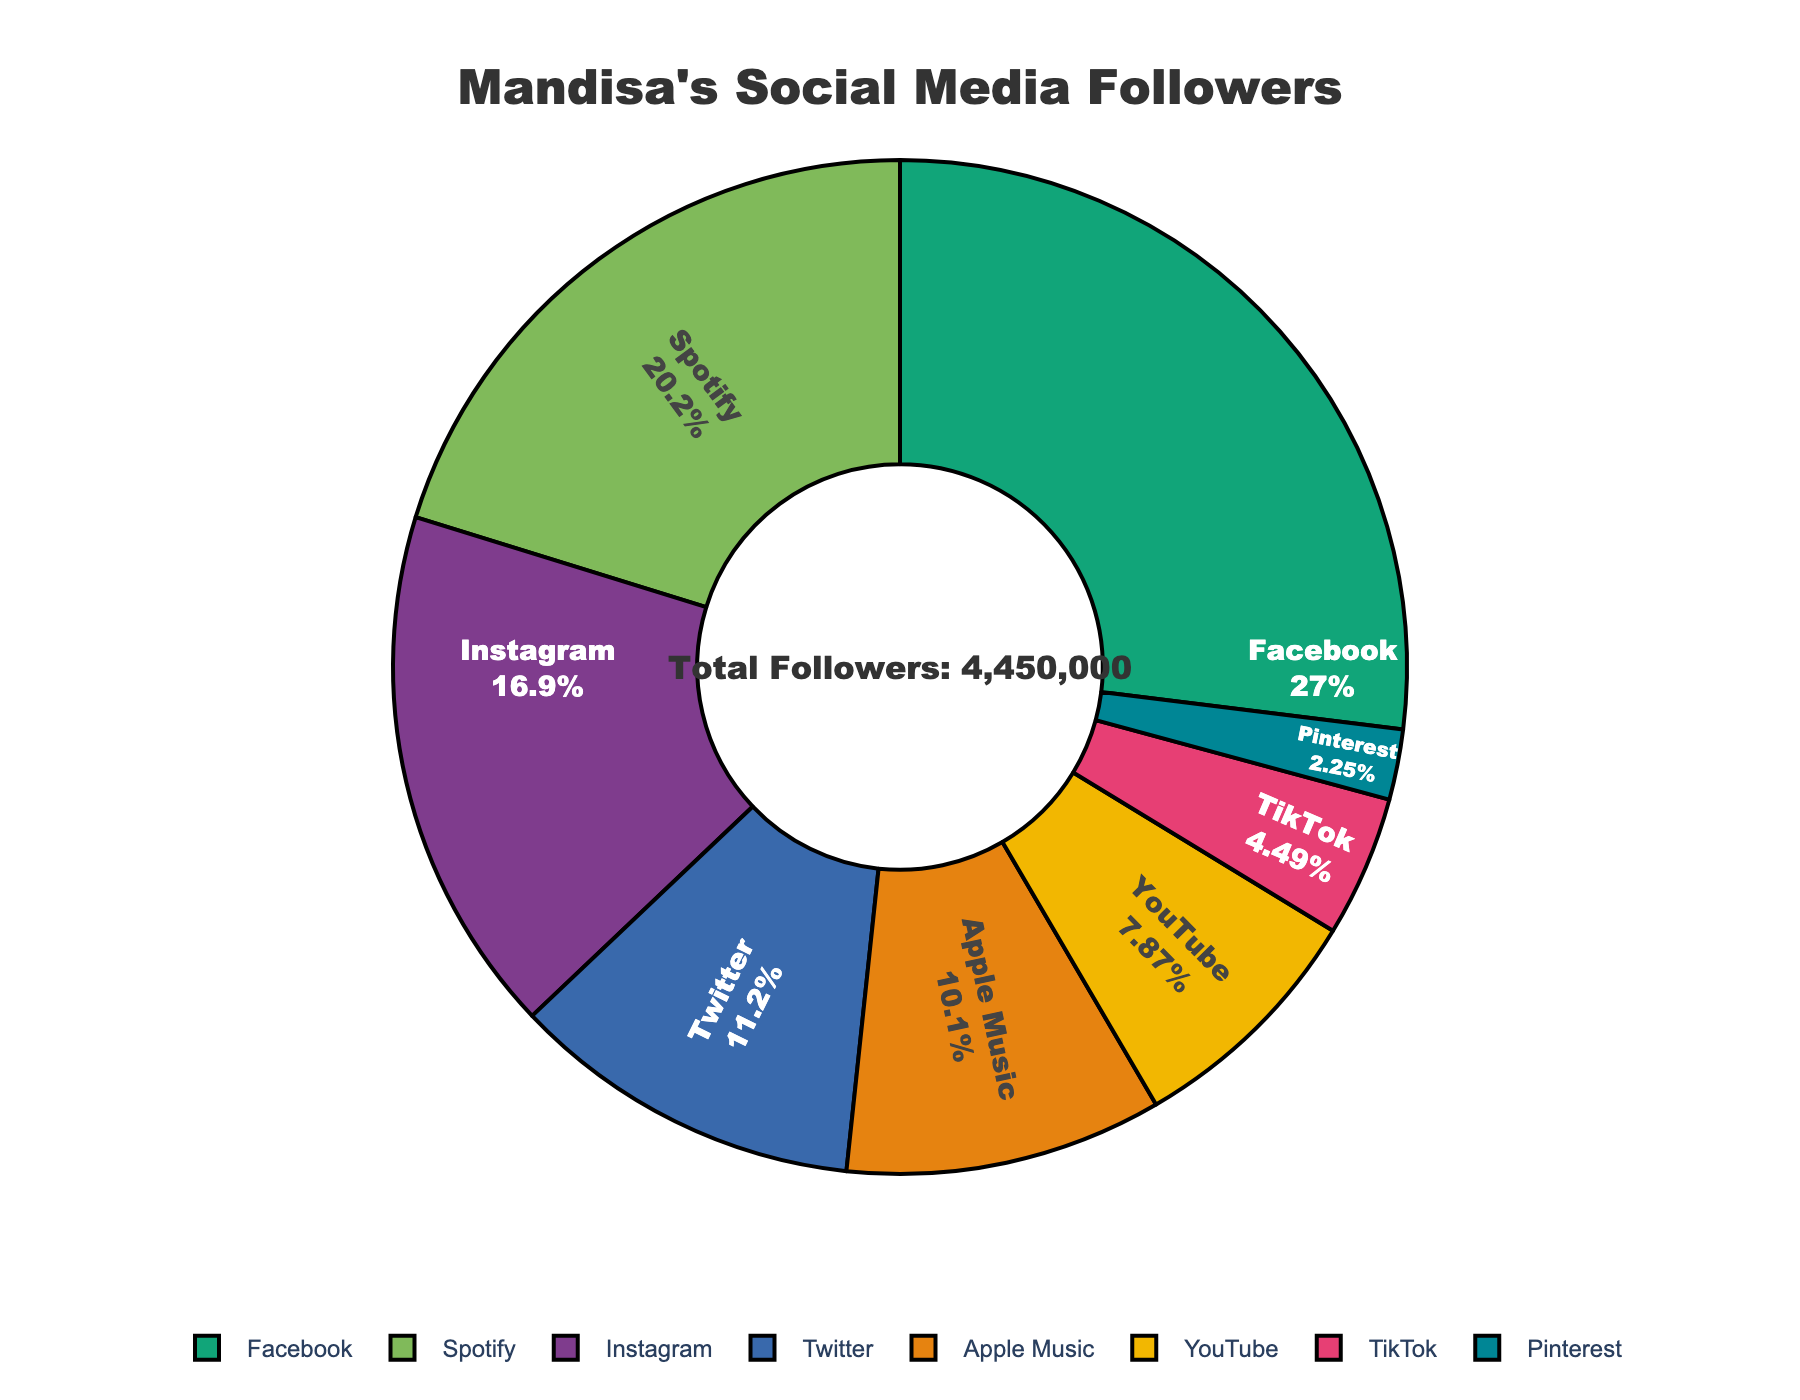What percentage of Mandisa's social media followers are on Instagram? To find the percentage of Instagram followers, we refer to the pie chart where Instagram is shown as a slice with its respective percentage label.
Answer: 20% Which platform has the highest number of followers? The platform with the largest slice in the pie chart represents the platform with the highest number of followers. Facebook has the largest slice.
Answer: Facebook How many more followers does Facebook have compared to Twitter? Look at the respective slices for Facebook and Twitter. Facebook's slice indicates 1,200,000 followers and Twitter's slice indicates 500,000 followers. The difference can be calculated as 1,200,000 - 500,000.
Answer: 700,000 What is the total number of followers across all platforms? The total number of followers is often indicated as an annotation in the pie chart. Alternatively, sum up the follower counts for all the platforms: 750,000 + 1,200,000 + 500,000 + 350,000 + 200,000 + 900,000 + 450,000 + 100,000
Answer: 4,450,000 What percentage of followers are on YouTube and Spotify combined? Locate the slices for YouTube and Spotify and add their percentage values together. From the chart, YouTube is 7.9% and Spotify is 20.2%. Add these percentages: 7.9% + 20.2% = 28.1%
Answer: 28.1% Between YouTube and TikTok, which has a higher percentage of Mandisa's followers, and by how much? Compare the slices for YouTube and TikTok. YouTube's percentage is 7.9% and TikTok's percentage is 4.5%. The difference is calculated as 7.9% - 4.5%.
Answer: YouTube by 3.4% What is the sum of followers on Pinterest and Apple Music? Find the number of followers from the chart for Pinterest (100,000) and Apple Music (450,000) and add them together: 100,000 + 450,000 = 550,000
Answer: 550,000 Which platform has the smallest share of followers? The platform with the smallest slice in the pie chart has the smallest share. Pinterest has the smallest slice.
Answer: Pinterest If Mandisa gains 100,000 more followers on TikTok, what will the new total number of followers be? Add the additional followers to the current total followers. The current total is 4,450,000. So, 4,450,000 + 100,000 = 4,550,000
Answer: 4,550,000 